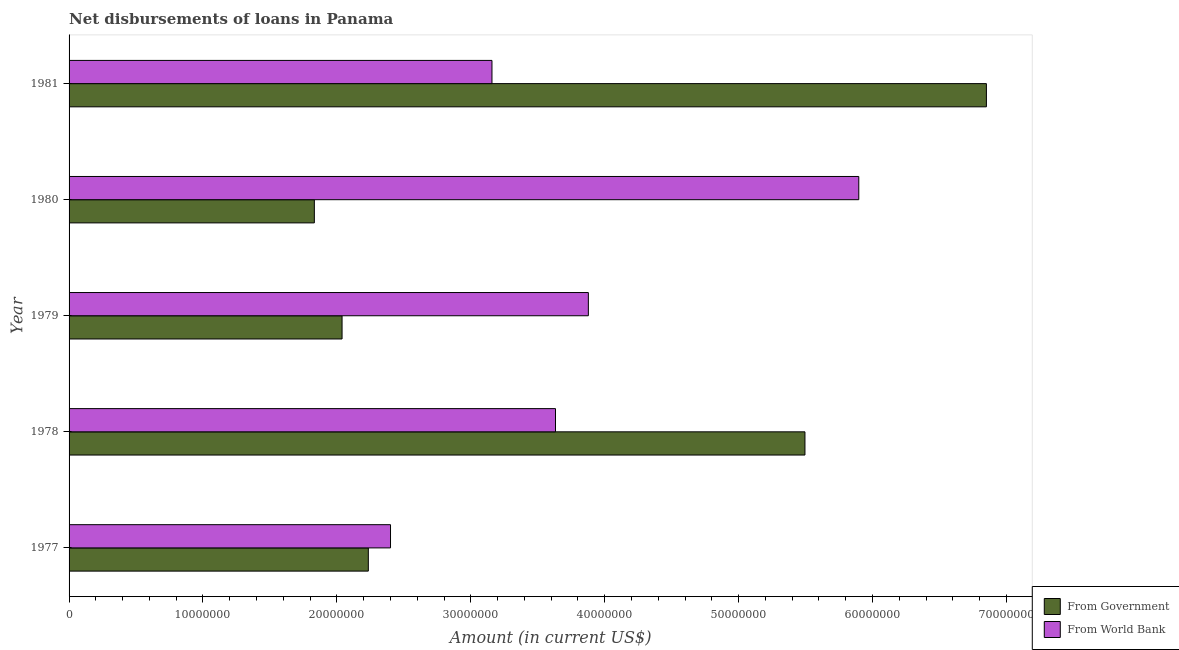How many different coloured bars are there?
Offer a terse response. 2. How many groups of bars are there?
Offer a terse response. 5. Are the number of bars per tick equal to the number of legend labels?
Your answer should be compact. Yes. What is the label of the 4th group of bars from the top?
Offer a very short reply. 1978. What is the net disbursements of loan from world bank in 1978?
Make the answer very short. 3.63e+07. Across all years, what is the maximum net disbursements of loan from world bank?
Make the answer very short. 5.90e+07. Across all years, what is the minimum net disbursements of loan from world bank?
Your answer should be compact. 2.40e+07. In which year was the net disbursements of loan from world bank minimum?
Offer a terse response. 1977. What is the total net disbursements of loan from world bank in the graph?
Provide a short and direct response. 1.90e+08. What is the difference between the net disbursements of loan from government in 1977 and that in 1981?
Give a very brief answer. -4.62e+07. What is the difference between the net disbursements of loan from government in 1980 and the net disbursements of loan from world bank in 1981?
Offer a very short reply. -1.33e+07. What is the average net disbursements of loan from government per year?
Your answer should be very brief. 3.69e+07. In the year 1978, what is the difference between the net disbursements of loan from world bank and net disbursements of loan from government?
Offer a terse response. -1.86e+07. In how many years, is the net disbursements of loan from world bank greater than 42000000 US$?
Your answer should be compact. 1. What is the ratio of the net disbursements of loan from government in 1977 to that in 1980?
Ensure brevity in your answer.  1.22. What is the difference between the highest and the second highest net disbursements of loan from world bank?
Your response must be concise. 2.02e+07. What is the difference between the highest and the lowest net disbursements of loan from government?
Your answer should be compact. 5.02e+07. In how many years, is the net disbursements of loan from world bank greater than the average net disbursements of loan from world bank taken over all years?
Keep it short and to the point. 2. Is the sum of the net disbursements of loan from world bank in 1978 and 1980 greater than the maximum net disbursements of loan from government across all years?
Your answer should be very brief. Yes. What does the 1st bar from the top in 1977 represents?
Your answer should be very brief. From World Bank. What does the 1st bar from the bottom in 1978 represents?
Provide a short and direct response. From Government. How many years are there in the graph?
Keep it short and to the point. 5. Does the graph contain any zero values?
Ensure brevity in your answer.  No. Does the graph contain grids?
Ensure brevity in your answer.  No. Where does the legend appear in the graph?
Make the answer very short. Bottom right. How are the legend labels stacked?
Ensure brevity in your answer.  Vertical. What is the title of the graph?
Your response must be concise. Net disbursements of loans in Panama. Does "Primary" appear as one of the legend labels in the graph?
Keep it short and to the point. No. What is the label or title of the X-axis?
Ensure brevity in your answer.  Amount (in current US$). What is the Amount (in current US$) in From Government in 1977?
Keep it short and to the point. 2.23e+07. What is the Amount (in current US$) of From World Bank in 1977?
Make the answer very short. 2.40e+07. What is the Amount (in current US$) of From Government in 1978?
Your response must be concise. 5.50e+07. What is the Amount (in current US$) in From World Bank in 1978?
Offer a very short reply. 3.63e+07. What is the Amount (in current US$) in From Government in 1979?
Offer a very short reply. 2.04e+07. What is the Amount (in current US$) of From World Bank in 1979?
Offer a terse response. 3.88e+07. What is the Amount (in current US$) of From Government in 1980?
Give a very brief answer. 1.83e+07. What is the Amount (in current US$) in From World Bank in 1980?
Your response must be concise. 5.90e+07. What is the Amount (in current US$) in From Government in 1981?
Provide a succinct answer. 6.85e+07. What is the Amount (in current US$) in From World Bank in 1981?
Your response must be concise. 3.16e+07. Across all years, what is the maximum Amount (in current US$) in From Government?
Give a very brief answer. 6.85e+07. Across all years, what is the maximum Amount (in current US$) of From World Bank?
Provide a succinct answer. 5.90e+07. Across all years, what is the minimum Amount (in current US$) of From Government?
Keep it short and to the point. 1.83e+07. Across all years, what is the minimum Amount (in current US$) in From World Bank?
Provide a succinct answer. 2.40e+07. What is the total Amount (in current US$) of From Government in the graph?
Keep it short and to the point. 1.85e+08. What is the total Amount (in current US$) in From World Bank in the graph?
Give a very brief answer. 1.90e+08. What is the difference between the Amount (in current US$) of From Government in 1977 and that in 1978?
Keep it short and to the point. -3.26e+07. What is the difference between the Amount (in current US$) in From World Bank in 1977 and that in 1978?
Your response must be concise. -1.23e+07. What is the difference between the Amount (in current US$) in From Government in 1977 and that in 1979?
Provide a succinct answer. 1.96e+06. What is the difference between the Amount (in current US$) in From World Bank in 1977 and that in 1979?
Ensure brevity in your answer.  -1.48e+07. What is the difference between the Amount (in current US$) of From Government in 1977 and that in 1980?
Offer a terse response. 4.03e+06. What is the difference between the Amount (in current US$) of From World Bank in 1977 and that in 1980?
Keep it short and to the point. -3.50e+07. What is the difference between the Amount (in current US$) of From Government in 1977 and that in 1981?
Offer a very short reply. -4.62e+07. What is the difference between the Amount (in current US$) of From World Bank in 1977 and that in 1981?
Give a very brief answer. -7.58e+06. What is the difference between the Amount (in current US$) in From Government in 1978 and that in 1979?
Offer a terse response. 3.46e+07. What is the difference between the Amount (in current US$) in From World Bank in 1978 and that in 1979?
Give a very brief answer. -2.45e+06. What is the difference between the Amount (in current US$) of From Government in 1978 and that in 1980?
Keep it short and to the point. 3.66e+07. What is the difference between the Amount (in current US$) of From World Bank in 1978 and that in 1980?
Keep it short and to the point. -2.26e+07. What is the difference between the Amount (in current US$) of From Government in 1978 and that in 1981?
Offer a very short reply. -1.36e+07. What is the difference between the Amount (in current US$) in From World Bank in 1978 and that in 1981?
Ensure brevity in your answer.  4.74e+06. What is the difference between the Amount (in current US$) in From Government in 1979 and that in 1980?
Your answer should be compact. 2.07e+06. What is the difference between the Amount (in current US$) in From World Bank in 1979 and that in 1980?
Provide a short and direct response. -2.02e+07. What is the difference between the Amount (in current US$) in From Government in 1979 and that in 1981?
Make the answer very short. -4.81e+07. What is the difference between the Amount (in current US$) of From World Bank in 1979 and that in 1981?
Give a very brief answer. 7.20e+06. What is the difference between the Amount (in current US$) in From Government in 1980 and that in 1981?
Keep it short and to the point. -5.02e+07. What is the difference between the Amount (in current US$) of From World Bank in 1980 and that in 1981?
Ensure brevity in your answer.  2.74e+07. What is the difference between the Amount (in current US$) in From Government in 1977 and the Amount (in current US$) in From World Bank in 1978?
Provide a succinct answer. -1.40e+07. What is the difference between the Amount (in current US$) in From Government in 1977 and the Amount (in current US$) in From World Bank in 1979?
Provide a short and direct response. -1.64e+07. What is the difference between the Amount (in current US$) in From Government in 1977 and the Amount (in current US$) in From World Bank in 1980?
Offer a terse response. -3.66e+07. What is the difference between the Amount (in current US$) in From Government in 1977 and the Amount (in current US$) in From World Bank in 1981?
Keep it short and to the point. -9.23e+06. What is the difference between the Amount (in current US$) of From Government in 1978 and the Amount (in current US$) of From World Bank in 1979?
Give a very brief answer. 1.62e+07. What is the difference between the Amount (in current US$) of From Government in 1978 and the Amount (in current US$) of From World Bank in 1980?
Ensure brevity in your answer.  -4.02e+06. What is the difference between the Amount (in current US$) in From Government in 1978 and the Amount (in current US$) in From World Bank in 1981?
Offer a terse response. 2.34e+07. What is the difference between the Amount (in current US$) in From Government in 1979 and the Amount (in current US$) in From World Bank in 1980?
Provide a short and direct response. -3.86e+07. What is the difference between the Amount (in current US$) in From Government in 1979 and the Amount (in current US$) in From World Bank in 1981?
Offer a terse response. -1.12e+07. What is the difference between the Amount (in current US$) of From Government in 1980 and the Amount (in current US$) of From World Bank in 1981?
Your answer should be very brief. -1.33e+07. What is the average Amount (in current US$) of From Government per year?
Make the answer very short. 3.69e+07. What is the average Amount (in current US$) of From World Bank per year?
Offer a very short reply. 3.79e+07. In the year 1977, what is the difference between the Amount (in current US$) in From Government and Amount (in current US$) in From World Bank?
Make the answer very short. -1.66e+06. In the year 1978, what is the difference between the Amount (in current US$) in From Government and Amount (in current US$) in From World Bank?
Keep it short and to the point. 1.86e+07. In the year 1979, what is the difference between the Amount (in current US$) in From Government and Amount (in current US$) in From World Bank?
Make the answer very short. -1.84e+07. In the year 1980, what is the difference between the Amount (in current US$) of From Government and Amount (in current US$) of From World Bank?
Give a very brief answer. -4.07e+07. In the year 1981, what is the difference between the Amount (in current US$) of From Government and Amount (in current US$) of From World Bank?
Your response must be concise. 3.69e+07. What is the ratio of the Amount (in current US$) of From Government in 1977 to that in 1978?
Provide a short and direct response. 0.41. What is the ratio of the Amount (in current US$) of From World Bank in 1977 to that in 1978?
Provide a short and direct response. 0.66. What is the ratio of the Amount (in current US$) of From Government in 1977 to that in 1979?
Your response must be concise. 1.1. What is the ratio of the Amount (in current US$) in From World Bank in 1977 to that in 1979?
Offer a very short reply. 0.62. What is the ratio of the Amount (in current US$) in From Government in 1977 to that in 1980?
Offer a very short reply. 1.22. What is the ratio of the Amount (in current US$) of From World Bank in 1977 to that in 1980?
Make the answer very short. 0.41. What is the ratio of the Amount (in current US$) in From Government in 1977 to that in 1981?
Your answer should be very brief. 0.33. What is the ratio of the Amount (in current US$) in From World Bank in 1977 to that in 1981?
Ensure brevity in your answer.  0.76. What is the ratio of the Amount (in current US$) of From Government in 1978 to that in 1979?
Make the answer very short. 2.7. What is the ratio of the Amount (in current US$) of From World Bank in 1978 to that in 1979?
Make the answer very short. 0.94. What is the ratio of the Amount (in current US$) in From Government in 1978 to that in 1980?
Your response must be concise. 3. What is the ratio of the Amount (in current US$) in From World Bank in 1978 to that in 1980?
Offer a terse response. 0.62. What is the ratio of the Amount (in current US$) in From Government in 1978 to that in 1981?
Offer a terse response. 0.8. What is the ratio of the Amount (in current US$) of From World Bank in 1978 to that in 1981?
Offer a very short reply. 1.15. What is the ratio of the Amount (in current US$) in From Government in 1979 to that in 1980?
Ensure brevity in your answer.  1.11. What is the ratio of the Amount (in current US$) in From World Bank in 1979 to that in 1980?
Keep it short and to the point. 0.66. What is the ratio of the Amount (in current US$) of From Government in 1979 to that in 1981?
Your response must be concise. 0.3. What is the ratio of the Amount (in current US$) of From World Bank in 1979 to that in 1981?
Your answer should be compact. 1.23. What is the ratio of the Amount (in current US$) of From Government in 1980 to that in 1981?
Offer a terse response. 0.27. What is the ratio of the Amount (in current US$) in From World Bank in 1980 to that in 1981?
Ensure brevity in your answer.  1.87. What is the difference between the highest and the second highest Amount (in current US$) of From Government?
Keep it short and to the point. 1.36e+07. What is the difference between the highest and the second highest Amount (in current US$) in From World Bank?
Provide a short and direct response. 2.02e+07. What is the difference between the highest and the lowest Amount (in current US$) of From Government?
Provide a succinct answer. 5.02e+07. What is the difference between the highest and the lowest Amount (in current US$) in From World Bank?
Provide a succinct answer. 3.50e+07. 